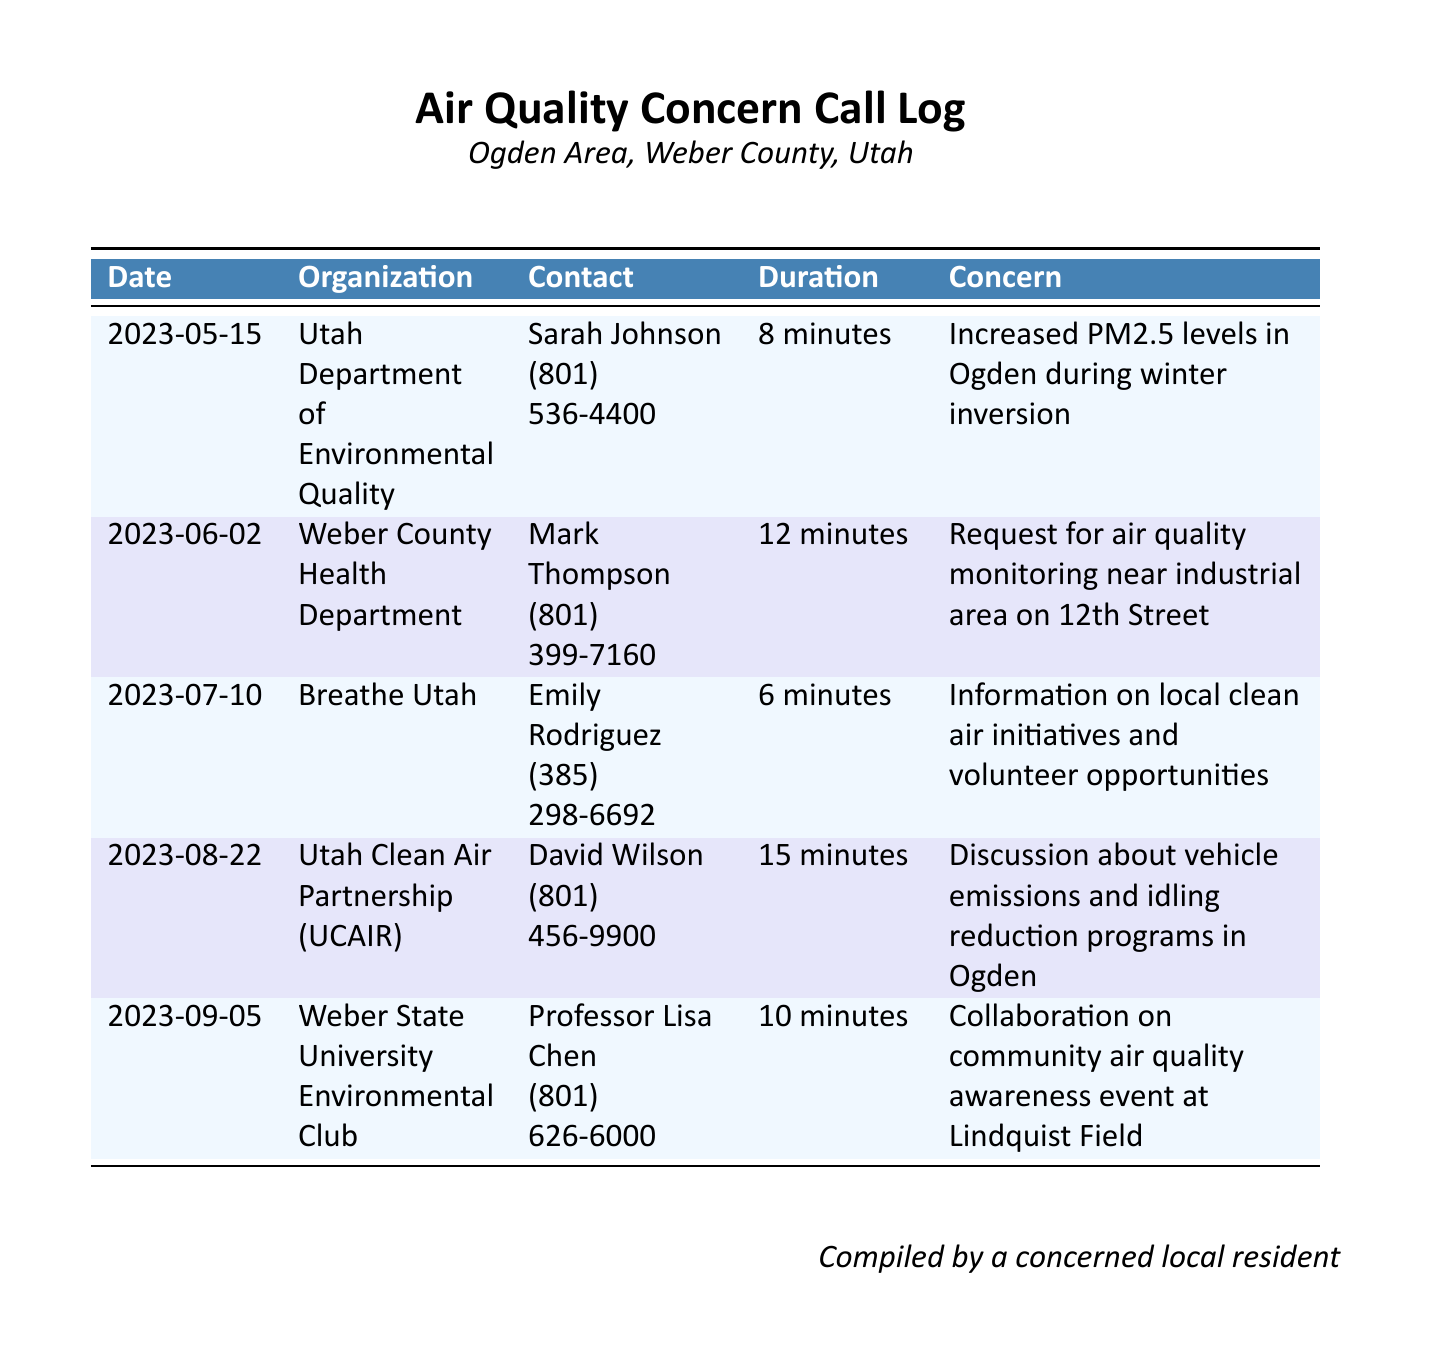What is the date of the call to the Utah Department of Environmental Quality? The document lists the date for that call as May 15, 2023.
Answer: May 15, 2023 Who is the contact person for Breathe Utah? Breathe Utah's contact person is Emily Rodriguez, as stated in the document.
Answer: Emily Rodriguez What was the concern discussed during the call to the Weber County Health Department? The concern was about air quality monitoring near an industrial area on 12th Street.
Answer: Air quality monitoring near industrial area on 12th Street How long was the call to the Utah Clean Air Partnership? The document indicates that the call lasted for 15 minutes.
Answer: 15 minutes Which organization discussed vehicle emissions and idling reduction programs? The organization that discussed these issues is the Utah Clean Air Partnership (UCAIR).
Answer: Utah Clean Air Partnership (UCAIR) Which date had the least call duration recorded? The call to Breathe Utah had the least duration, which was 6 minutes.
Answer: 6 minutes What type of event was the Weber State University Environmental Club collaborating on? The club was collaborating on a community air quality awareness event.
Answer: Community air quality awareness event Who compiled the document? The document acknowledges that it was compiled by a concerned local resident.
Answer: A concerned local resident 